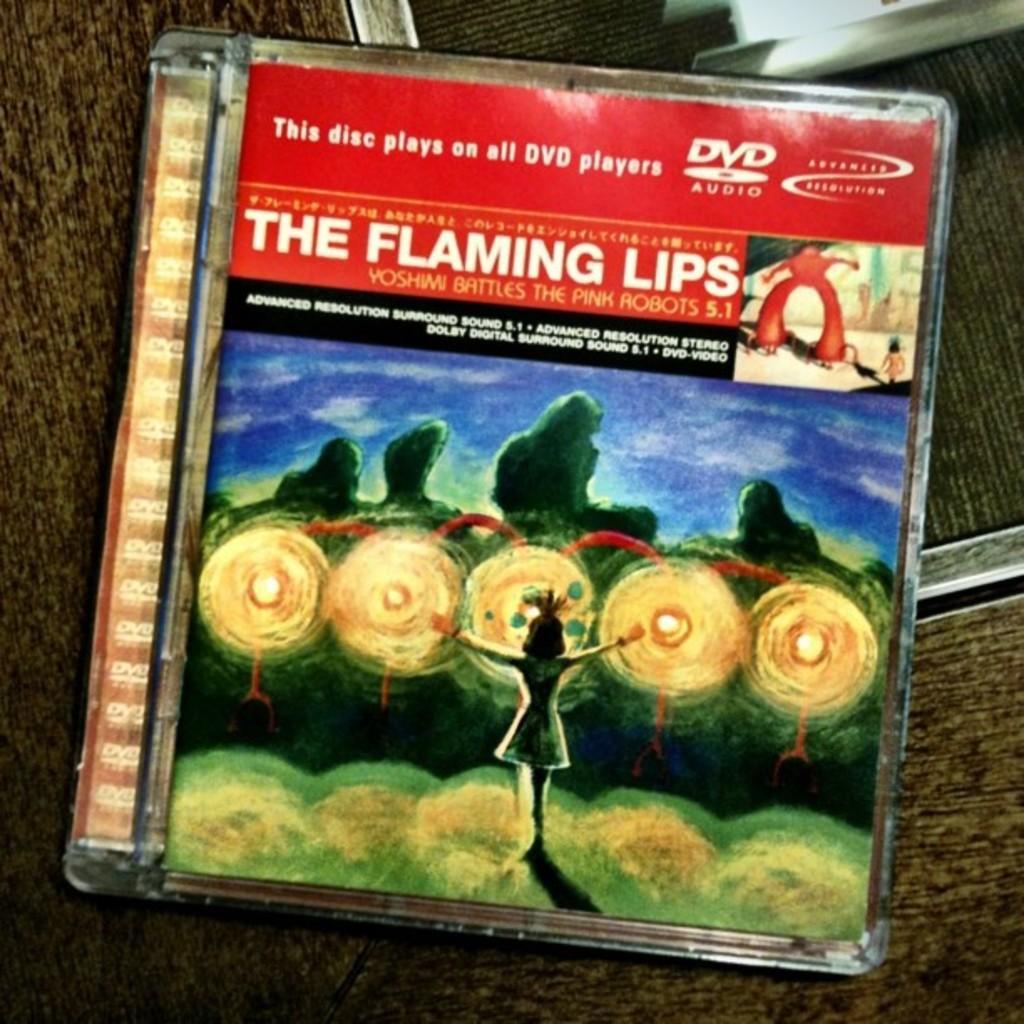How would you summarize this image in a sentence or two? In this image we can see DVD box on the surface. 